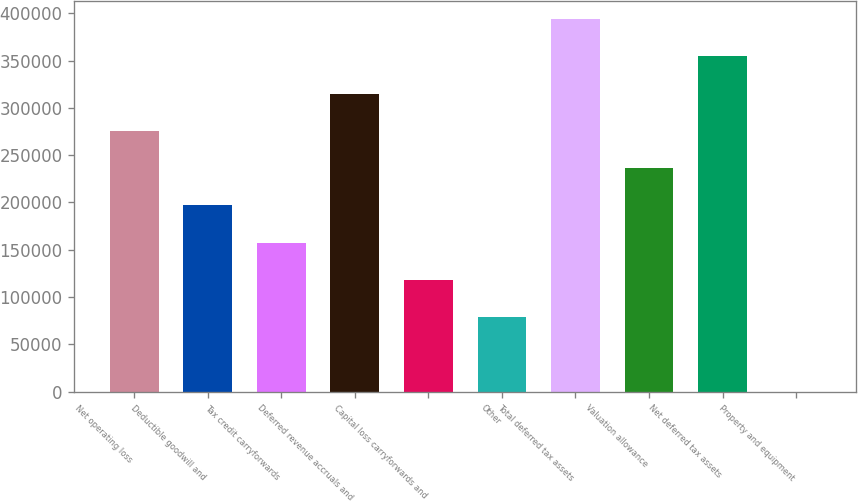Convert chart to OTSL. <chart><loc_0><loc_0><loc_500><loc_500><bar_chart><fcel>Net operating loss<fcel>Deductible goodwill and<fcel>Tax credit carryforwards<fcel>Deferred revenue accruals and<fcel>Capital loss carryforwards and<fcel>Other<fcel>Total deferred tax assets<fcel>Valuation allowance<fcel>Net deferred tax assets<fcel>Property and equipment<nl><fcel>275625<fcel>196887<fcel>157518<fcel>314994<fcel>118149<fcel>78780<fcel>393732<fcel>236256<fcel>354363<fcel>42<nl></chart> 